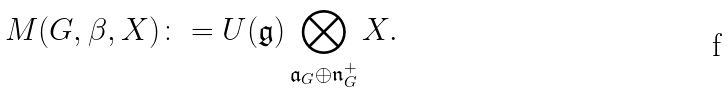<formula> <loc_0><loc_0><loc_500><loc_500>M ( G , \beta , X ) \colon = U ( \mathfrak { g } ) \bigotimes _ { \mathfrak { a } _ { G } \oplus \mathfrak { n } ^ { + } _ { G } } X .</formula> 